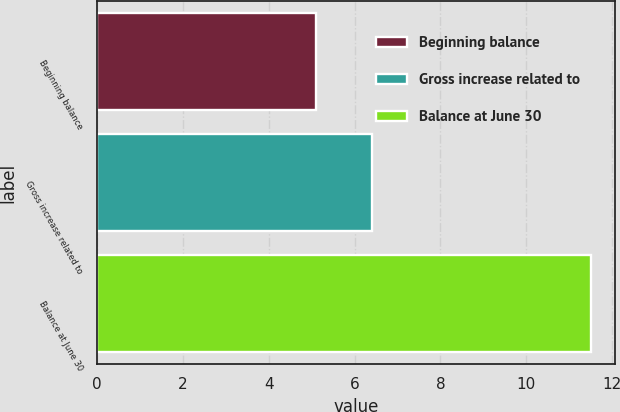Convert chart to OTSL. <chart><loc_0><loc_0><loc_500><loc_500><bar_chart><fcel>Beginning balance<fcel>Gross increase related to<fcel>Balance at June 30<nl><fcel>5.1<fcel>6.4<fcel>11.5<nl></chart> 